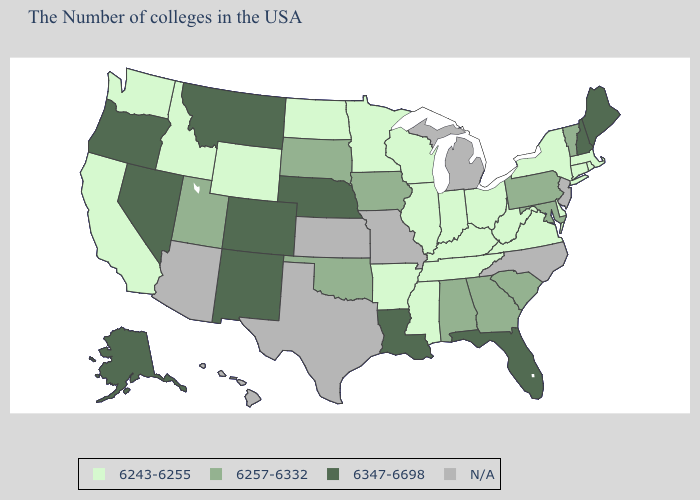What is the value of Tennessee?
Concise answer only. 6243-6255. What is the lowest value in the Northeast?
Concise answer only. 6243-6255. What is the value of Alabama?
Write a very short answer. 6257-6332. Does Ohio have the lowest value in the MidWest?
Short answer required. Yes. What is the lowest value in the West?
Be succinct. 6243-6255. How many symbols are there in the legend?
Quick response, please. 4. Does Alaska have the highest value in the West?
Quick response, please. Yes. What is the value of Vermont?
Quick response, please. 6257-6332. What is the value of Kansas?
Write a very short answer. N/A. What is the highest value in states that border West Virginia?
Keep it brief. 6257-6332. Name the states that have a value in the range N/A?
Give a very brief answer. New Jersey, North Carolina, Michigan, Missouri, Kansas, Texas, Arizona, Hawaii. Does the first symbol in the legend represent the smallest category?
Keep it brief. Yes. Does the first symbol in the legend represent the smallest category?
Short answer required. Yes. Which states have the lowest value in the West?
Keep it brief. Wyoming, Idaho, California, Washington. 